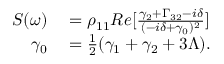<formula> <loc_0><loc_0><loc_500><loc_500>\begin{array} { r l } { S ( \omega ) } & = \rho _ { 1 1 } R e [ \frac { \gamma _ { 2 } + \Gamma _ { 3 2 } - i \delta } { ( - i \delta + \gamma _ { 0 } ) ^ { 2 } } ] } \\ { \gamma _ { 0 } } & = \frac { 1 } { 2 } ( \gamma _ { 1 } + \gamma _ { 2 } + 3 \Lambda ) . } \end{array}</formula> 